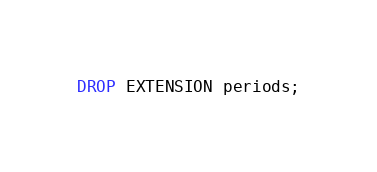Convert code to text. <code><loc_0><loc_0><loc_500><loc_500><_SQL_>DROP EXTENSION periods;
</code> 